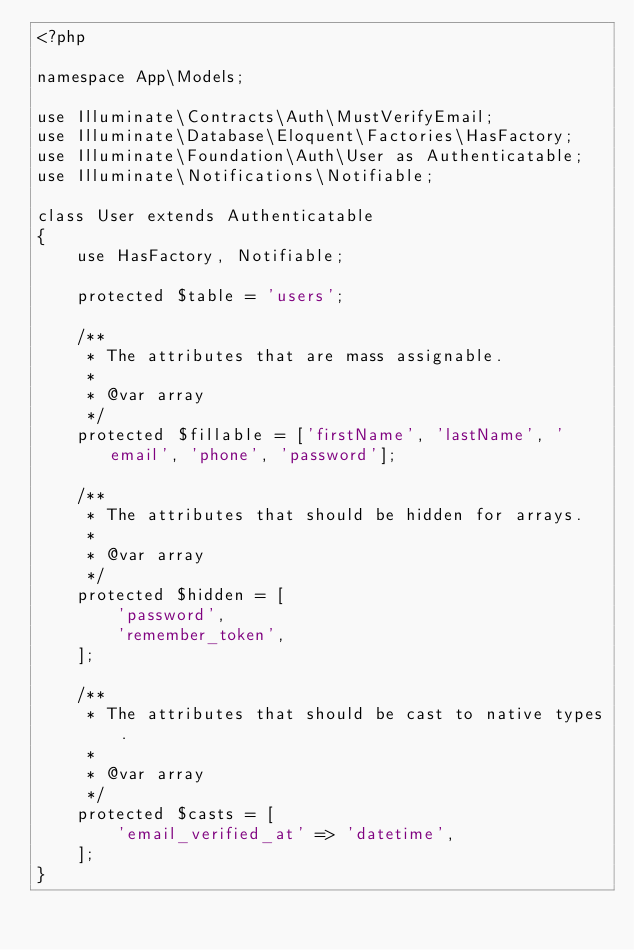<code> <loc_0><loc_0><loc_500><loc_500><_PHP_><?php

namespace App\Models;

use Illuminate\Contracts\Auth\MustVerifyEmail;
use Illuminate\Database\Eloquent\Factories\HasFactory;
use Illuminate\Foundation\Auth\User as Authenticatable;
use Illuminate\Notifications\Notifiable;

class User extends Authenticatable
{
    use HasFactory, Notifiable;

    protected $table = 'users';

    /**
     * The attributes that are mass assignable.
     *
     * @var array
     */
    protected $fillable = ['firstName', 'lastName', 'email', 'phone', 'password'];

    /**
     * The attributes that should be hidden for arrays.
     *
     * @var array
     */
    protected $hidden = [
        'password',
        'remember_token',
    ];

    /**
     * The attributes that should be cast to native types.
     *
     * @var array
     */
    protected $casts = [
        'email_verified_at' => 'datetime',
    ];
}
</code> 